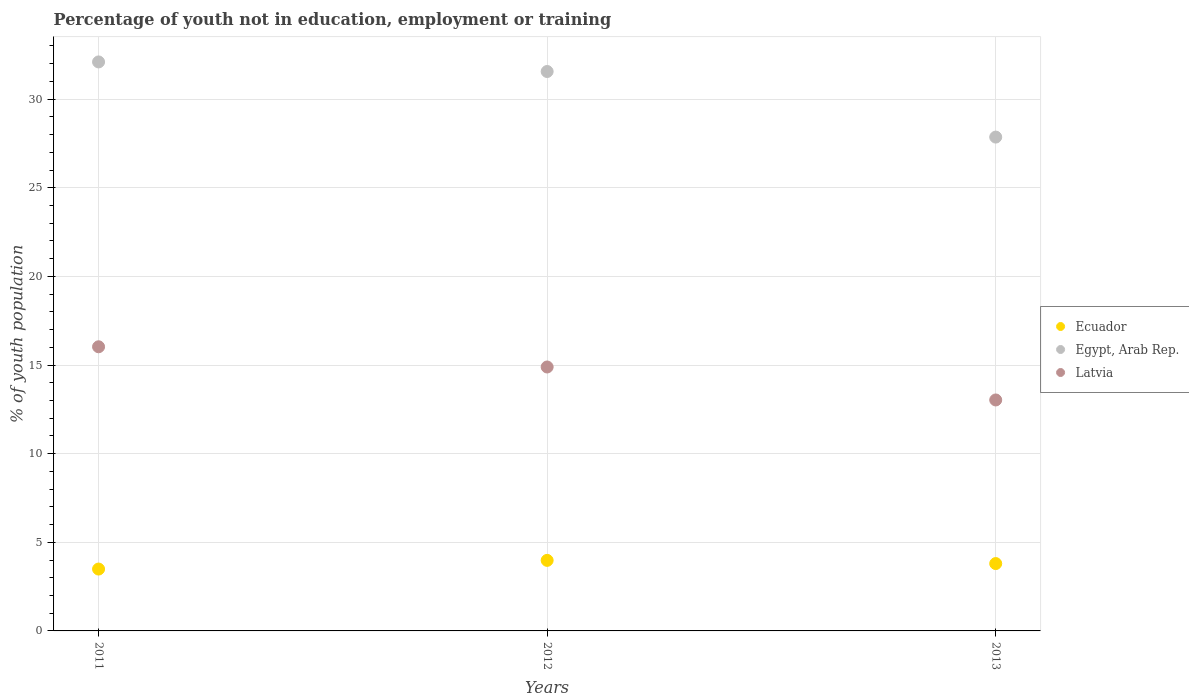Is the number of dotlines equal to the number of legend labels?
Ensure brevity in your answer.  Yes. What is the percentage of unemployed youth population in in Ecuador in 2013?
Make the answer very short. 3.8. Across all years, what is the maximum percentage of unemployed youth population in in Egypt, Arab Rep.?
Give a very brief answer. 32.1. Across all years, what is the minimum percentage of unemployed youth population in in Ecuador?
Provide a short and direct response. 3.49. In which year was the percentage of unemployed youth population in in Egypt, Arab Rep. maximum?
Provide a short and direct response. 2011. What is the total percentage of unemployed youth population in in Egypt, Arab Rep. in the graph?
Keep it short and to the point. 91.52. What is the difference between the percentage of unemployed youth population in in Latvia in 2011 and that in 2012?
Offer a very short reply. 1.14. What is the difference between the percentage of unemployed youth population in in Ecuador in 2011 and the percentage of unemployed youth population in in Egypt, Arab Rep. in 2012?
Ensure brevity in your answer.  -28.07. What is the average percentage of unemployed youth population in in Ecuador per year?
Your answer should be compact. 3.76. In the year 2013, what is the difference between the percentage of unemployed youth population in in Ecuador and percentage of unemployed youth population in in Latvia?
Give a very brief answer. -9.23. In how many years, is the percentage of unemployed youth population in in Latvia greater than 5 %?
Make the answer very short. 3. What is the ratio of the percentage of unemployed youth population in in Egypt, Arab Rep. in 2011 to that in 2013?
Your answer should be very brief. 1.15. Is the difference between the percentage of unemployed youth population in in Ecuador in 2012 and 2013 greater than the difference between the percentage of unemployed youth population in in Latvia in 2012 and 2013?
Your response must be concise. No. What is the difference between the highest and the second highest percentage of unemployed youth population in in Ecuador?
Your answer should be very brief. 0.18. What is the difference between the highest and the lowest percentage of unemployed youth population in in Latvia?
Offer a very short reply. 3. Is the percentage of unemployed youth population in in Latvia strictly less than the percentage of unemployed youth population in in Egypt, Arab Rep. over the years?
Give a very brief answer. Yes. How many dotlines are there?
Offer a very short reply. 3. How many years are there in the graph?
Your response must be concise. 3. Are the values on the major ticks of Y-axis written in scientific E-notation?
Provide a succinct answer. No. Where does the legend appear in the graph?
Offer a terse response. Center right. How are the legend labels stacked?
Your answer should be very brief. Vertical. What is the title of the graph?
Provide a succinct answer. Percentage of youth not in education, employment or training. What is the label or title of the Y-axis?
Your answer should be compact. % of youth population. What is the % of youth population in Ecuador in 2011?
Provide a short and direct response. 3.49. What is the % of youth population in Egypt, Arab Rep. in 2011?
Your answer should be compact. 32.1. What is the % of youth population in Latvia in 2011?
Offer a terse response. 16.03. What is the % of youth population in Ecuador in 2012?
Make the answer very short. 3.98. What is the % of youth population of Egypt, Arab Rep. in 2012?
Your answer should be compact. 31.56. What is the % of youth population of Latvia in 2012?
Your response must be concise. 14.89. What is the % of youth population in Ecuador in 2013?
Your answer should be very brief. 3.8. What is the % of youth population in Egypt, Arab Rep. in 2013?
Provide a succinct answer. 27.86. What is the % of youth population in Latvia in 2013?
Offer a terse response. 13.03. Across all years, what is the maximum % of youth population in Ecuador?
Your answer should be very brief. 3.98. Across all years, what is the maximum % of youth population of Egypt, Arab Rep.?
Offer a terse response. 32.1. Across all years, what is the maximum % of youth population in Latvia?
Your answer should be compact. 16.03. Across all years, what is the minimum % of youth population in Ecuador?
Your answer should be compact. 3.49. Across all years, what is the minimum % of youth population of Egypt, Arab Rep.?
Keep it short and to the point. 27.86. Across all years, what is the minimum % of youth population in Latvia?
Provide a short and direct response. 13.03. What is the total % of youth population of Ecuador in the graph?
Ensure brevity in your answer.  11.27. What is the total % of youth population in Egypt, Arab Rep. in the graph?
Your answer should be compact. 91.52. What is the total % of youth population in Latvia in the graph?
Keep it short and to the point. 43.95. What is the difference between the % of youth population of Ecuador in 2011 and that in 2012?
Keep it short and to the point. -0.49. What is the difference between the % of youth population of Egypt, Arab Rep. in 2011 and that in 2012?
Give a very brief answer. 0.54. What is the difference between the % of youth population in Latvia in 2011 and that in 2012?
Keep it short and to the point. 1.14. What is the difference between the % of youth population in Ecuador in 2011 and that in 2013?
Your response must be concise. -0.31. What is the difference between the % of youth population of Egypt, Arab Rep. in 2011 and that in 2013?
Offer a terse response. 4.24. What is the difference between the % of youth population in Latvia in 2011 and that in 2013?
Ensure brevity in your answer.  3. What is the difference between the % of youth population in Ecuador in 2012 and that in 2013?
Offer a terse response. 0.18. What is the difference between the % of youth population in Latvia in 2012 and that in 2013?
Your answer should be compact. 1.86. What is the difference between the % of youth population in Ecuador in 2011 and the % of youth population in Egypt, Arab Rep. in 2012?
Your answer should be compact. -28.07. What is the difference between the % of youth population in Ecuador in 2011 and the % of youth population in Latvia in 2012?
Your response must be concise. -11.4. What is the difference between the % of youth population of Egypt, Arab Rep. in 2011 and the % of youth population of Latvia in 2012?
Make the answer very short. 17.21. What is the difference between the % of youth population of Ecuador in 2011 and the % of youth population of Egypt, Arab Rep. in 2013?
Your answer should be very brief. -24.37. What is the difference between the % of youth population in Ecuador in 2011 and the % of youth population in Latvia in 2013?
Provide a short and direct response. -9.54. What is the difference between the % of youth population of Egypt, Arab Rep. in 2011 and the % of youth population of Latvia in 2013?
Make the answer very short. 19.07. What is the difference between the % of youth population in Ecuador in 2012 and the % of youth population in Egypt, Arab Rep. in 2013?
Offer a terse response. -23.88. What is the difference between the % of youth population of Ecuador in 2012 and the % of youth population of Latvia in 2013?
Provide a short and direct response. -9.05. What is the difference between the % of youth population of Egypt, Arab Rep. in 2012 and the % of youth population of Latvia in 2013?
Provide a succinct answer. 18.53. What is the average % of youth population of Ecuador per year?
Give a very brief answer. 3.76. What is the average % of youth population of Egypt, Arab Rep. per year?
Your answer should be very brief. 30.51. What is the average % of youth population in Latvia per year?
Provide a succinct answer. 14.65. In the year 2011, what is the difference between the % of youth population in Ecuador and % of youth population in Egypt, Arab Rep.?
Provide a short and direct response. -28.61. In the year 2011, what is the difference between the % of youth population of Ecuador and % of youth population of Latvia?
Your response must be concise. -12.54. In the year 2011, what is the difference between the % of youth population of Egypt, Arab Rep. and % of youth population of Latvia?
Offer a very short reply. 16.07. In the year 2012, what is the difference between the % of youth population of Ecuador and % of youth population of Egypt, Arab Rep.?
Your answer should be very brief. -27.58. In the year 2012, what is the difference between the % of youth population of Ecuador and % of youth population of Latvia?
Give a very brief answer. -10.91. In the year 2012, what is the difference between the % of youth population of Egypt, Arab Rep. and % of youth population of Latvia?
Your response must be concise. 16.67. In the year 2013, what is the difference between the % of youth population of Ecuador and % of youth population of Egypt, Arab Rep.?
Offer a terse response. -24.06. In the year 2013, what is the difference between the % of youth population in Ecuador and % of youth population in Latvia?
Offer a very short reply. -9.23. In the year 2013, what is the difference between the % of youth population of Egypt, Arab Rep. and % of youth population of Latvia?
Provide a short and direct response. 14.83. What is the ratio of the % of youth population of Ecuador in 2011 to that in 2012?
Your response must be concise. 0.88. What is the ratio of the % of youth population in Egypt, Arab Rep. in 2011 to that in 2012?
Provide a succinct answer. 1.02. What is the ratio of the % of youth population in Latvia in 2011 to that in 2012?
Ensure brevity in your answer.  1.08. What is the ratio of the % of youth population of Ecuador in 2011 to that in 2013?
Offer a very short reply. 0.92. What is the ratio of the % of youth population in Egypt, Arab Rep. in 2011 to that in 2013?
Your response must be concise. 1.15. What is the ratio of the % of youth population of Latvia in 2011 to that in 2013?
Provide a short and direct response. 1.23. What is the ratio of the % of youth population of Ecuador in 2012 to that in 2013?
Your answer should be very brief. 1.05. What is the ratio of the % of youth population in Egypt, Arab Rep. in 2012 to that in 2013?
Offer a terse response. 1.13. What is the ratio of the % of youth population of Latvia in 2012 to that in 2013?
Give a very brief answer. 1.14. What is the difference between the highest and the second highest % of youth population of Ecuador?
Make the answer very short. 0.18. What is the difference between the highest and the second highest % of youth population of Egypt, Arab Rep.?
Offer a terse response. 0.54. What is the difference between the highest and the second highest % of youth population of Latvia?
Give a very brief answer. 1.14. What is the difference between the highest and the lowest % of youth population in Ecuador?
Offer a terse response. 0.49. What is the difference between the highest and the lowest % of youth population of Egypt, Arab Rep.?
Your response must be concise. 4.24. 